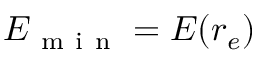<formula> <loc_0><loc_0><loc_500><loc_500>E _ { m i n } = E ( r _ { e } )</formula> 